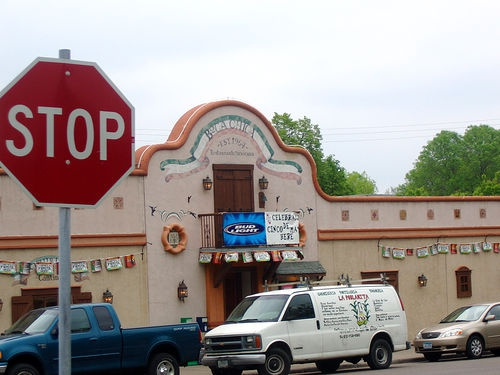Describe the objects in this image and their specific colors. I can see stop sign in white, maroon, darkgray, gray, and brown tones, truck in white, black, blue, gray, and darkblue tones, and car in white, black, gray, lightgray, and darkgray tones in this image. 